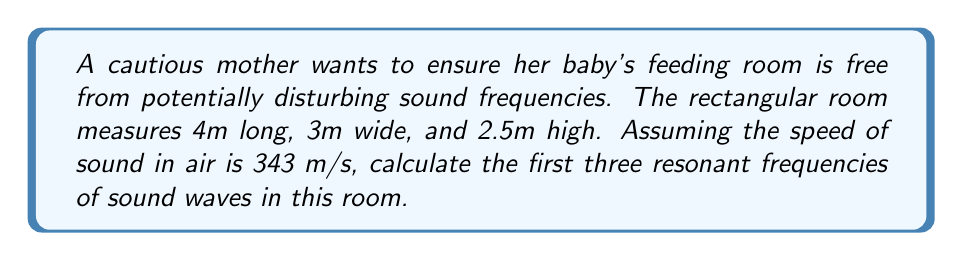Give your solution to this math problem. To find the resonant frequencies, we'll use the equation for standing waves in a rectangular room:

$$f_{l,m,n} = \frac{c}{2}\sqrt{\left(\frac{l}{L_x}\right)^2 + \left(\frac{m}{L_y}\right)^2 + \left(\frac{n}{L_z}\right)^2}$$

Where:
- $f_{l,m,n}$ is the resonant frequency
- $c$ is the speed of sound (343 m/s)
- $L_x$, $L_y$, and $L_z$ are the room dimensions (4m, 3m, and 2.5m respectively)
- $l$, $m$, and $n$ are non-negative integers (not all zero)

Step 1: Calculate the first resonant frequency (1,0,0):
$$f_{1,0,0} = \frac{343}{2}\sqrt{\left(\frac{1}{4}\right)^2 + 0^2 + 0^2} = 42.875 \text{ Hz}$$

Step 2: Calculate the second resonant frequency (0,1,0):
$$f_{0,1,0} = \frac{343}{2}\sqrt{0^2 + \left(\frac{1}{3}\right)^2 + 0^2} = 57.167 \text{ Hz}$$

Step 3: Calculate the third resonant frequency (0,0,1):
$$f_{0,0,1} = \frac{343}{2}\sqrt{0^2 + 0^2 + \left(\frac{1}{2.5}\right)^2} = 68.6 \text{ Hz}$$
Answer: 42.875 Hz, 57.167 Hz, 68.6 Hz 